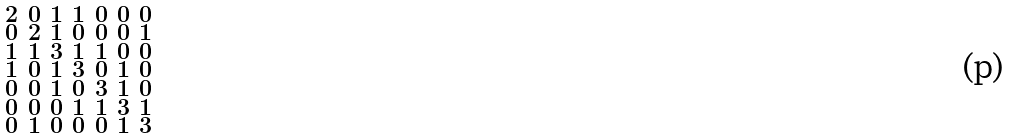Convert formula to latex. <formula><loc_0><loc_0><loc_500><loc_500>\begin{smallmatrix} 2 & 0 & 1 & 1 & 0 & 0 & 0 \\ 0 & 2 & 1 & 0 & 0 & 0 & 1 \\ 1 & 1 & 3 & 1 & 1 & 0 & 0 \\ 1 & 0 & 1 & 3 & 0 & 1 & 0 \\ 0 & 0 & 1 & 0 & 3 & 1 & 0 \\ 0 & 0 & 0 & 1 & 1 & 3 & 1 \\ 0 & 1 & 0 & 0 & 0 & 1 & 3 \end{smallmatrix}</formula> 